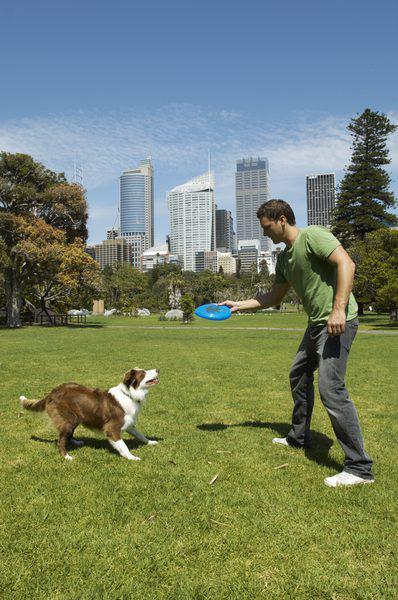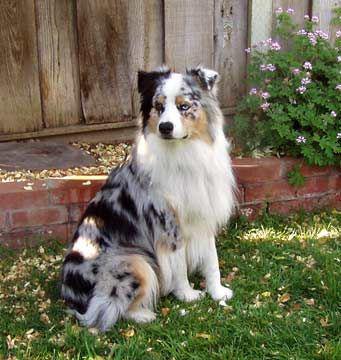The first image is the image on the left, the second image is the image on the right. Examine the images to the left and right. Is the description "There is no more than two dogs." accurate? Answer yes or no. Yes. The first image is the image on the left, the second image is the image on the right. Assess this claim about the two images: "The left image includes one brown-and-white dog, and the right image shows one multi-colored spotted dog.". Correct or not? Answer yes or no. Yes. 